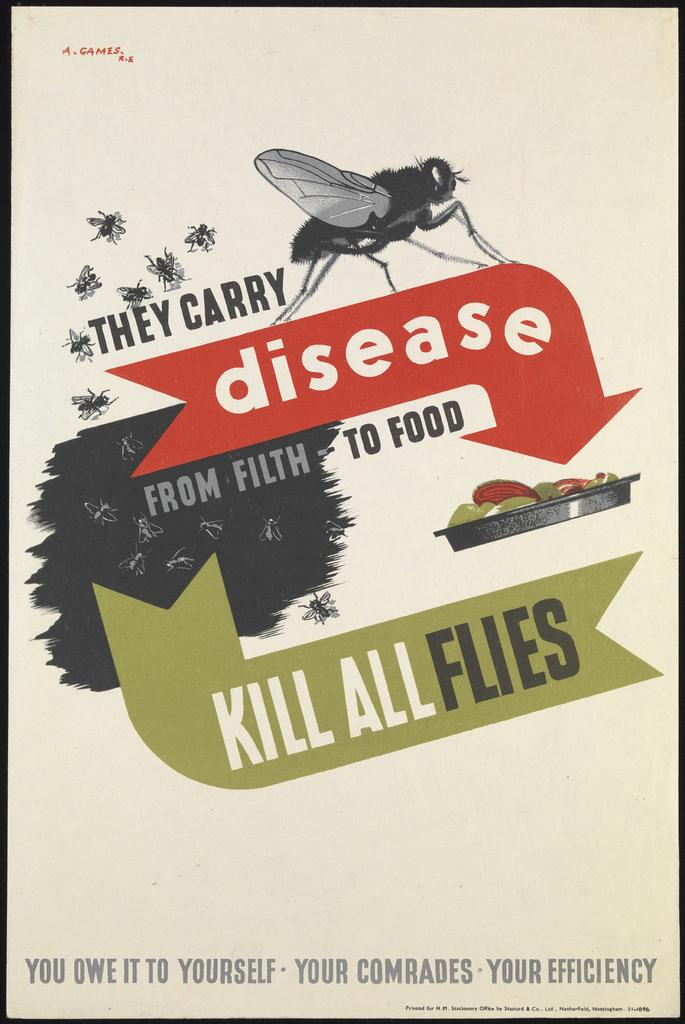What is featured in the picture? There is a poster in the picture. What can be seen on the poster? The poster depicts flies and food. Is there any text on the poster? Yes, there is writing on the poster. How many bears can be seen interacting with the rabbits at the zoo in the image? There are no bears, rabbits, or zoo present in the image; it features a poster with flies and food. 